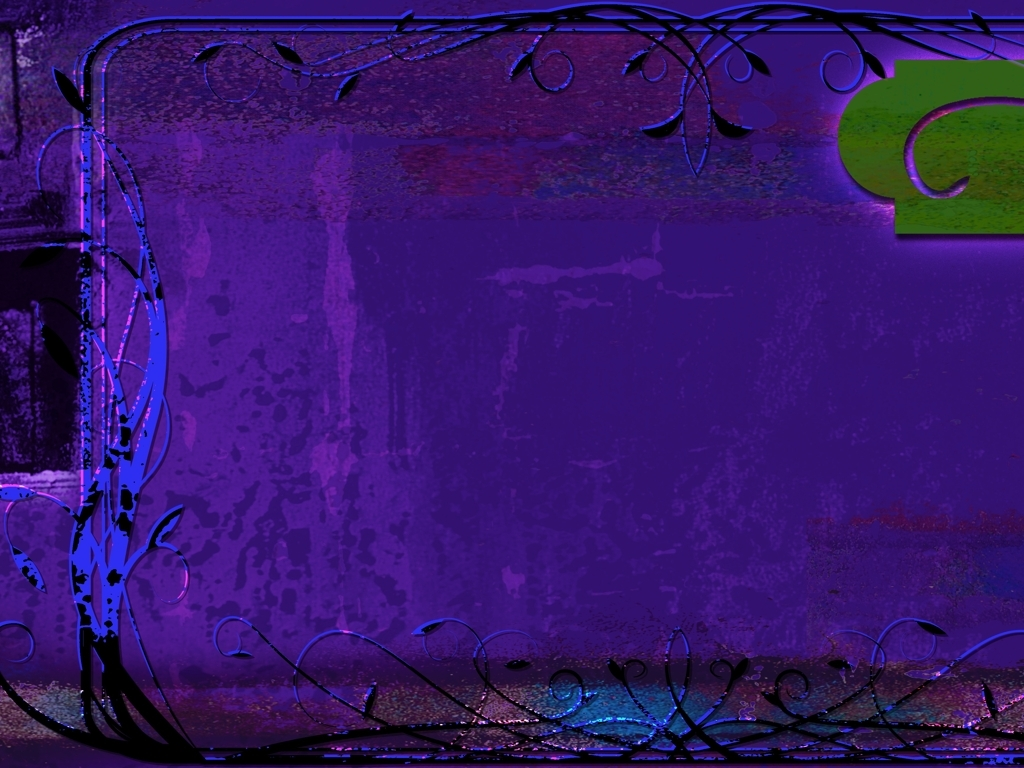What does the overall composition of this picture present?
A. chaos
B. realism
C. artistic style The overall composition of the image exudes an artistic style, characterized by abstract elements, a vivid use of colors, and ornate designs that suggest a sense of fantasy or whimsy. It moves away from realism, embracing an aesthetic that seems to prioritize emotional expression and creative design over lifelike depiction. 